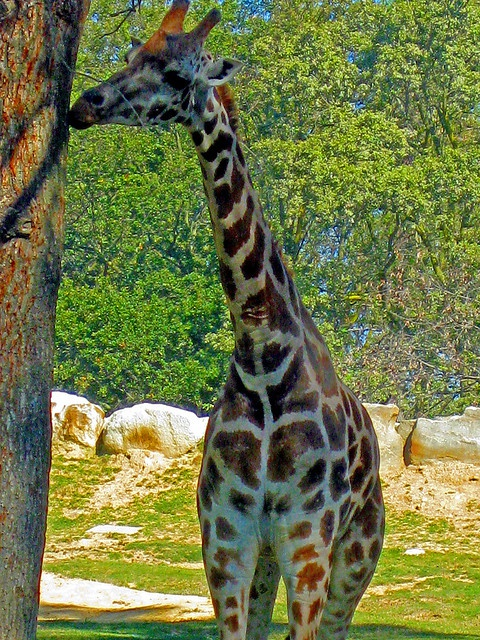Describe the objects in this image and their specific colors. I can see a giraffe in black, gray, darkgreen, and maroon tones in this image. 